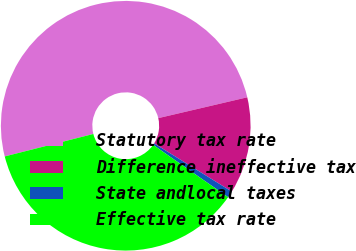Convert chart. <chart><loc_0><loc_0><loc_500><loc_500><pie_chart><fcel>Statutory tax rate<fcel>Difference ineffective tax<fcel>State andlocal taxes<fcel>Effective tax rate<nl><fcel>50.29%<fcel>12.5%<fcel>0.86%<fcel>36.35%<nl></chart> 